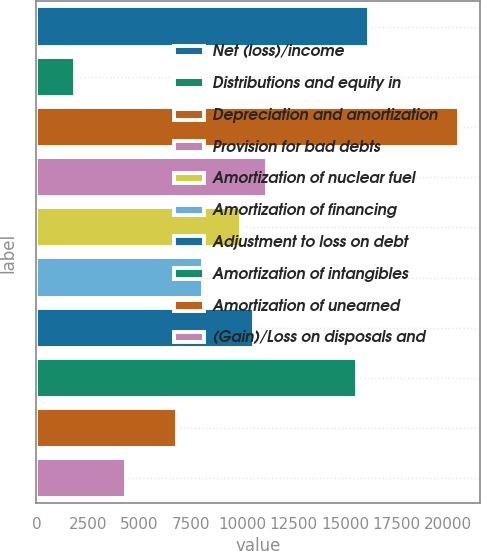<chart> <loc_0><loc_0><loc_500><loc_500><bar_chart><fcel>Net (loss)/income<fcel>Distributions and equity in<fcel>Depreciation and amortization<fcel>Provision for bad debts<fcel>Amortization of nuclear fuel<fcel>Amortization of financing<fcel>Adjustment to loss on debt<fcel>Amortization of intangibles<fcel>Amortization of unearned<fcel>(Gain)/Loss on disposals and<nl><fcel>16179.2<fcel>1868.6<fcel>20534.6<fcel>11201.6<fcel>9957.2<fcel>8090.6<fcel>10579.4<fcel>15557<fcel>6846.2<fcel>4357.4<nl></chart> 